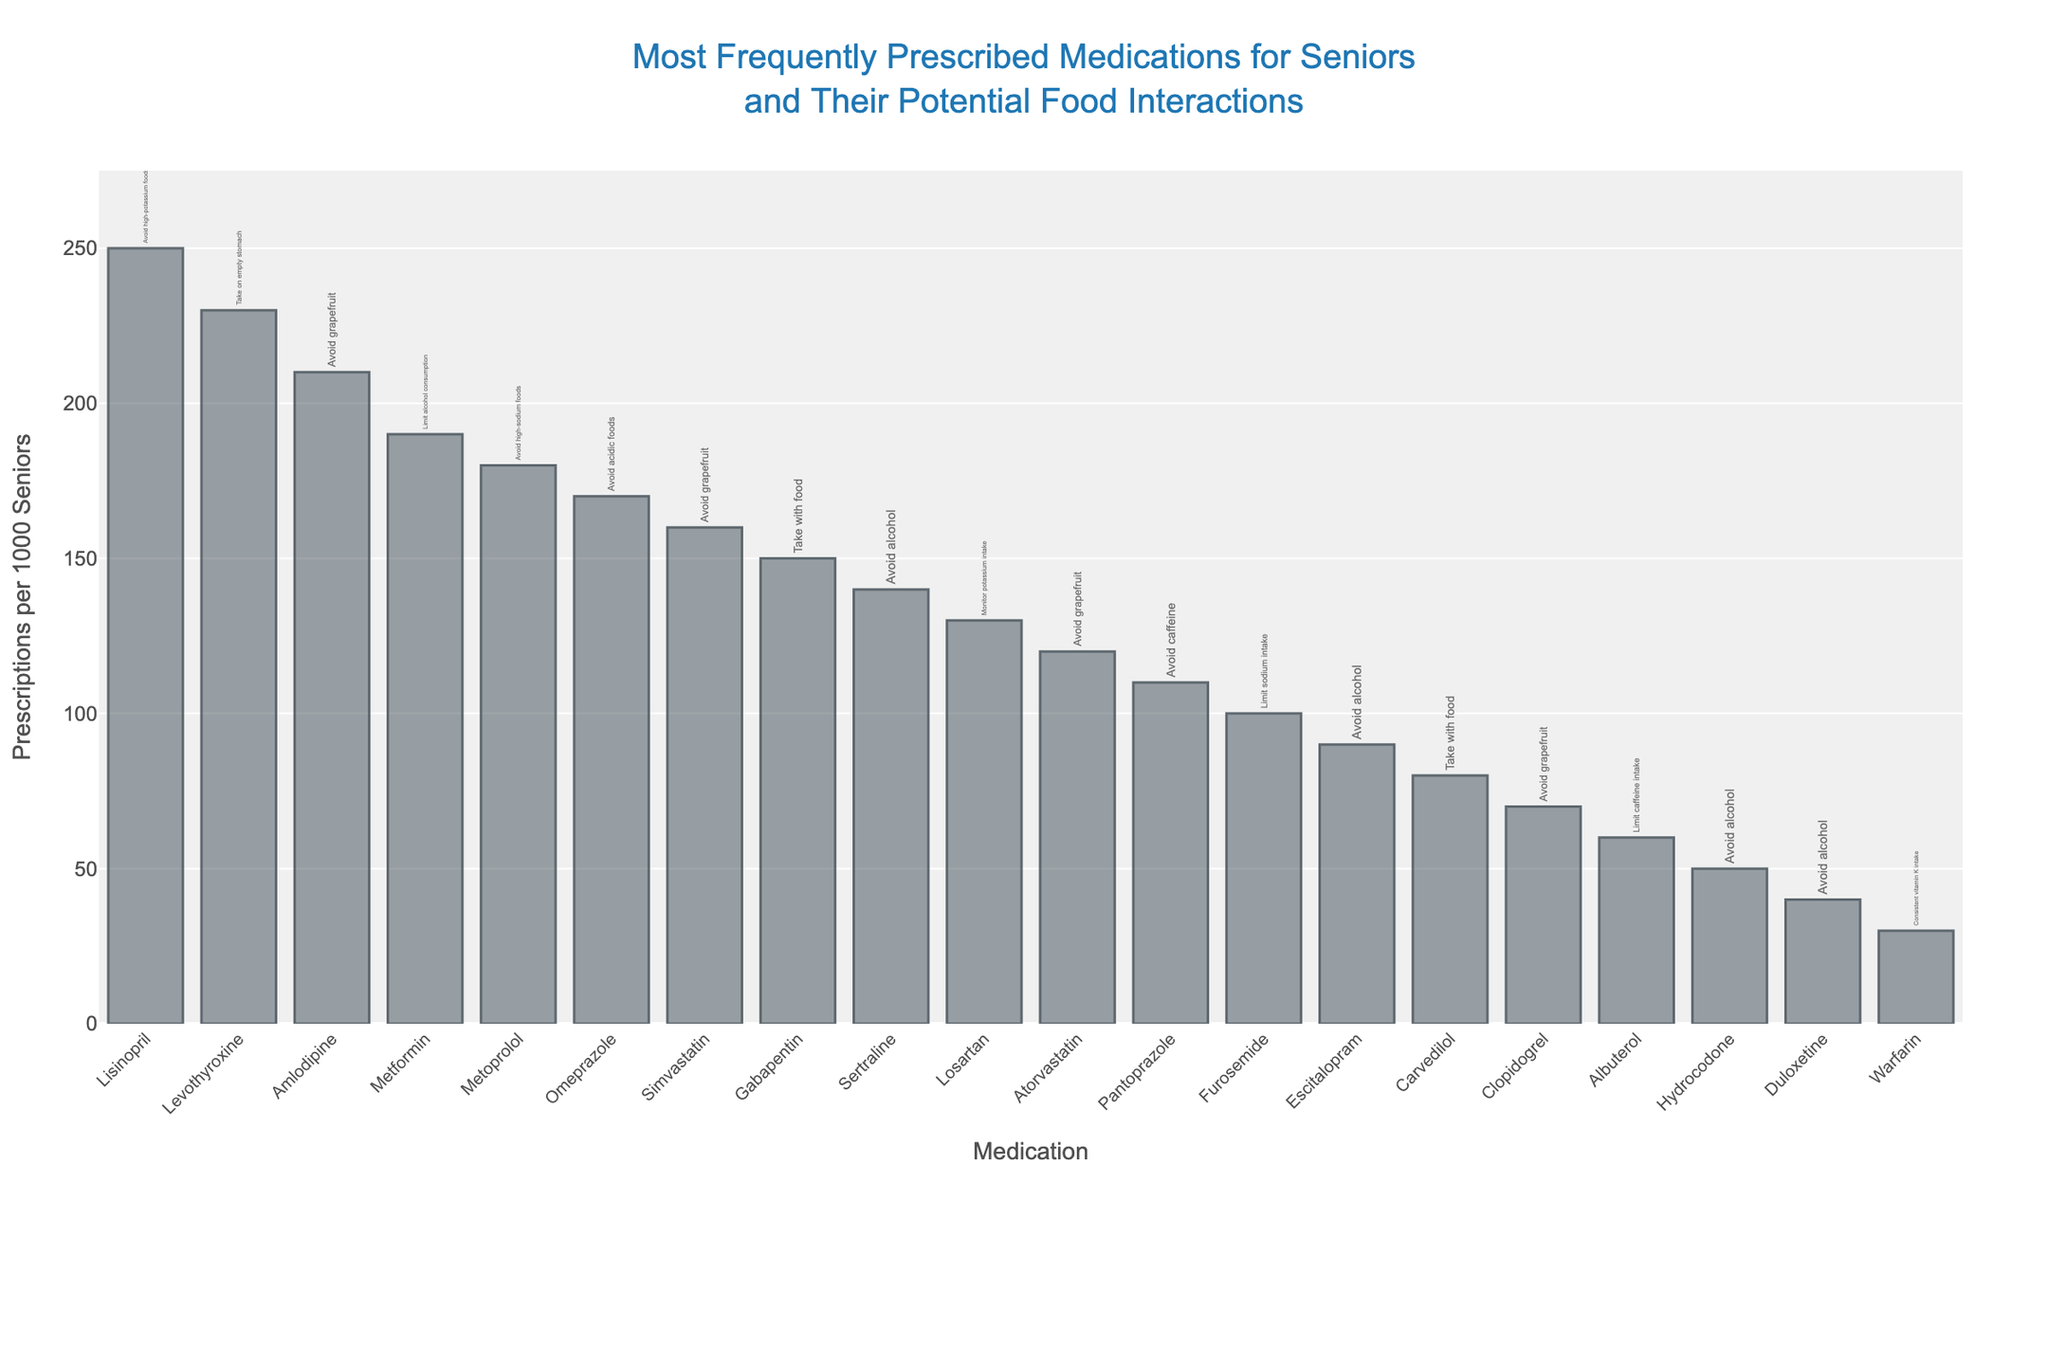Which medication has the highest number of prescriptions per 1000 seniors? The bar with the longest height represents the medication with the highest number of prescriptions. In the figure, Lisinopril is the tallest bar, indicating it has the highest number of prescriptions per 1000 seniors.
Answer: Lisinopril What is the potential food interaction for Levothyroxine? The text labeling next to the bar for Levothyroxine contains the potential food interaction, which states "Take on empty stomach."
Answer: Take on empty stomach How many medications have grapefruit as a potential food interaction? By looking at the textual labels next to each bar, we can count how many mention "Avoid grapefruit." In the figure, Amlodipine, Simvastatin, Atorvastatin, and Clopidogrel all suggest avoiding grapefruit.
Answer: 4 Compare the number of prescriptions per 1000 seniors between Metformin and Omeprazole. Which one is higher and by how much? From the bar heights, Metformin has 190 prescriptions per 1000 seniors while Omeprazole has 170. Subtract Omeprazole's count from Metformin's to find the difference: 190 - 170 = 20.
Answer: Metformin by 20 What is the average number of prescriptions per 1000 seniors for Lisinopril, Levothyroxine, and Amlodipine? To find the average, sum the prescriptions for these three medications and divide by 3. Lisinopril: 250, Levothyroxine: 230, Amlodipine: 210. Sum = 250 + 230 + 210 = 690. Average = 690 / 3 = 230.
Answer: 230 How many medications have alcohol as a potential food interaction? Look at the textual labels and count how many mention "Avoid alcohol." In the figure, Sertraline, Escitalopram, Hydrocodone, and Duloxetine all have this interaction.
Answer: 4 Which medication advises limiting caffeine intake? Check the textual labels for any mention of caffeine. Albuterol's label indicates "Limit caffeine intake."
Answer: Albuterol What is the total number of prescriptions per 1000 seniors for the medications with a food interaction involving potassium? Identify the medications with a potassium-related food interaction: Lisinopril and Losartan. Sum their prescriptions: Lisinopril 250 + Losartan 130. Total = 250 + 130 = 380.
Answer: 380 Is Furosemide prescribed more frequently than Escitalopram? Compare the height of the bars for Furosemide and Escitalopram. Furosemide has 100 prescriptions per 1000 seniors, while Escitalopram has 90. Hence, Furosemide is prescribed more.
Answer: Yes Which medications are advised to be taken with food? Check the labels for mentions of taking with food. Gabapentin and Carvedilol both have this advice.
Answer: Gabapentin, Carvedilol 